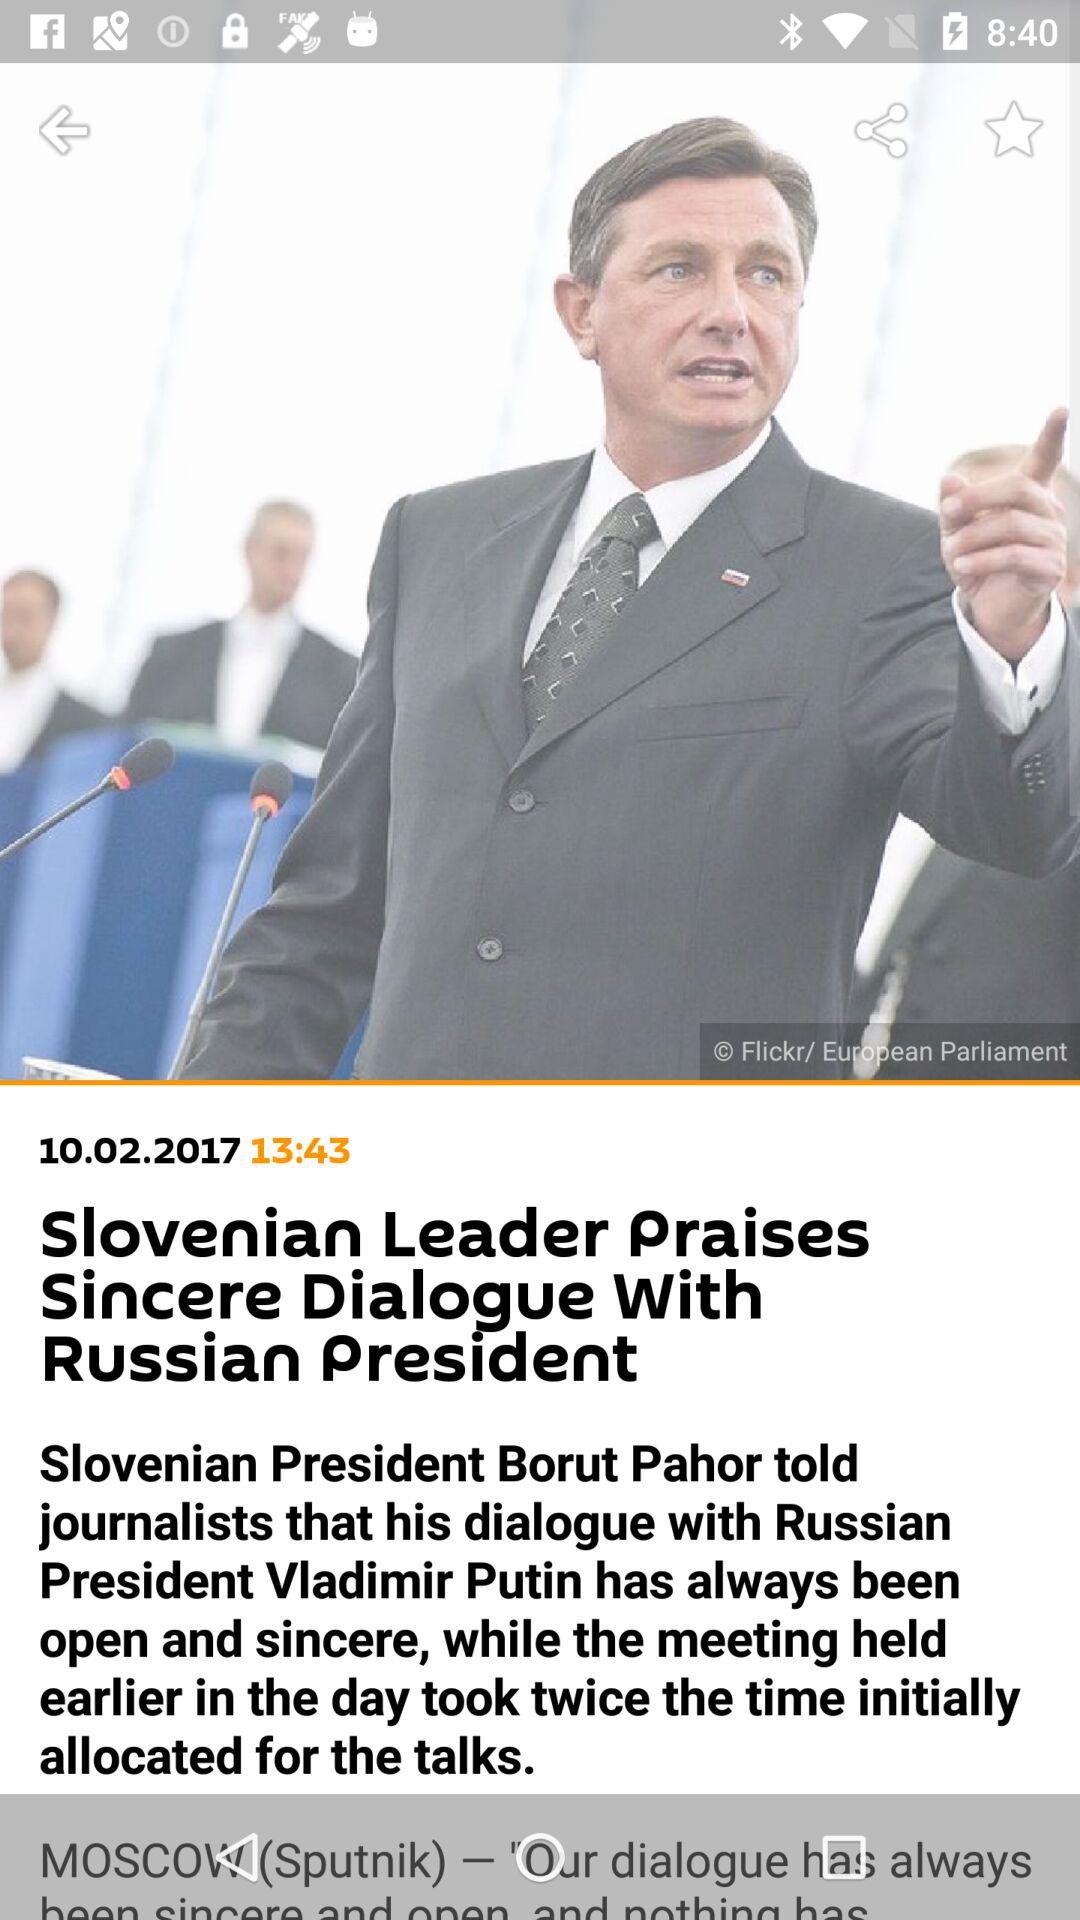What is the given time? The given time is 13:43. 